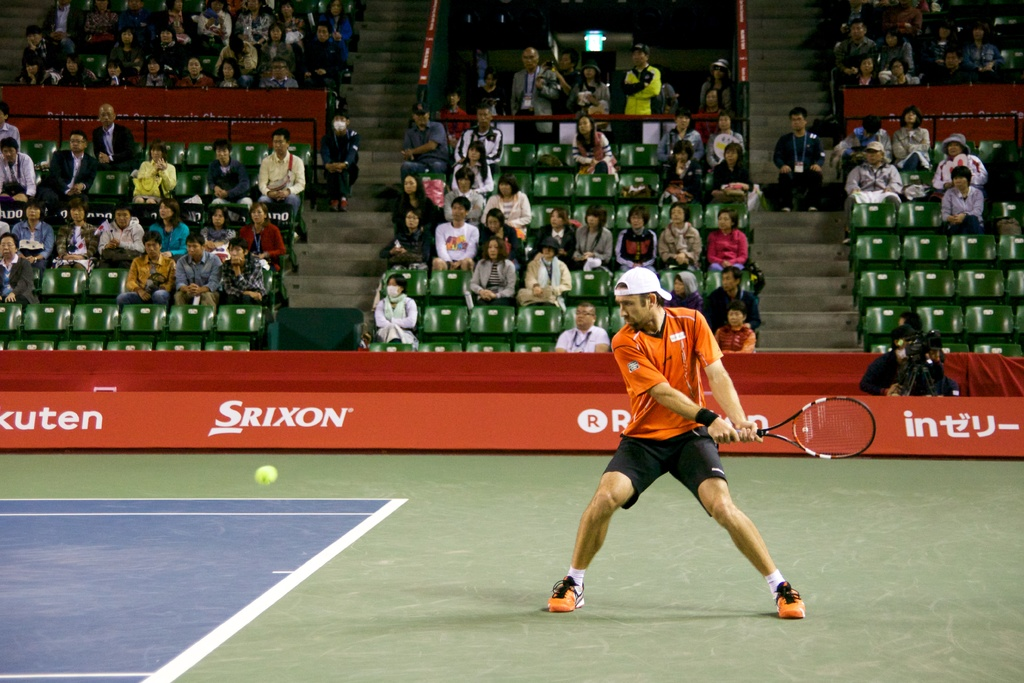Can you tell me more about the player's posture and equipment? The player is in a typical ready position for returning a serve, indicating excellent preparation and focus. He's equipped with a red racquet, likely a model from Srixon, dressed in professional tennis attire that provides optimal movement and comfort during the game. 